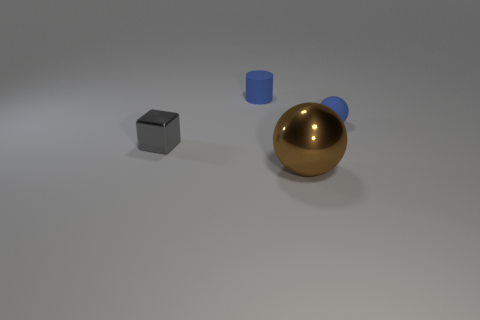Add 3 shiny spheres. How many objects exist? 7 Add 2 large brown metal spheres. How many large brown metal spheres exist? 3 Subtract 0 gray spheres. How many objects are left? 4 Subtract all cylinders. How many objects are left? 3 Subtract all yellow cylinders. Subtract all yellow spheres. How many cylinders are left? 1 Subtract all small green blocks. Subtract all small shiny cubes. How many objects are left? 3 Add 3 gray metal cubes. How many gray metal cubes are left? 4 